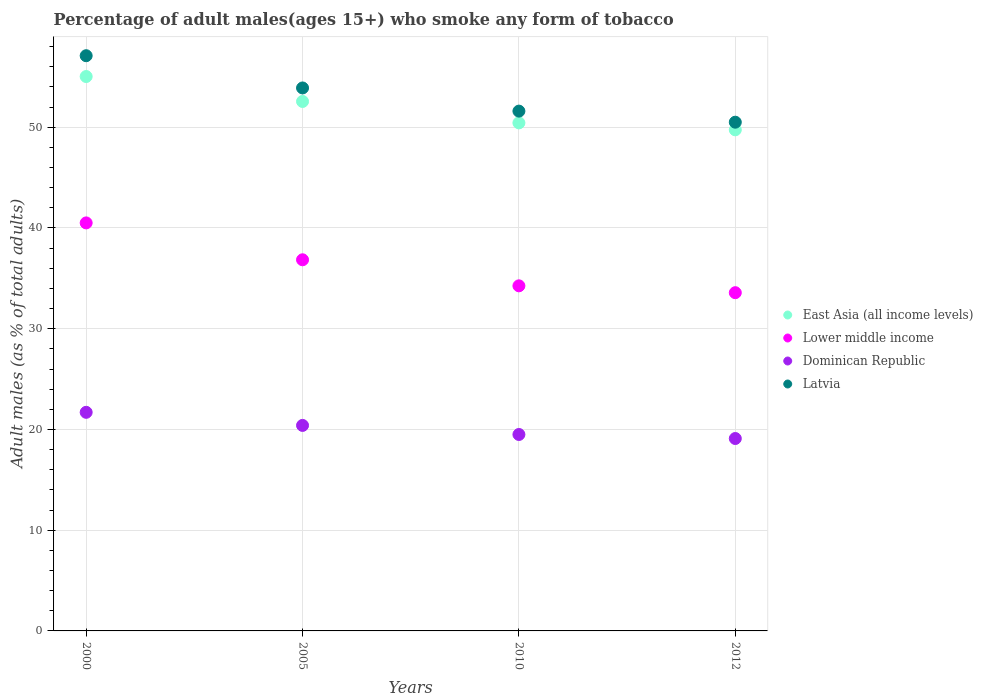How many different coloured dotlines are there?
Provide a succinct answer. 4. What is the percentage of adult males who smoke in Latvia in 2012?
Provide a succinct answer. 50.5. Across all years, what is the maximum percentage of adult males who smoke in Dominican Republic?
Your answer should be compact. 21.7. In which year was the percentage of adult males who smoke in Latvia maximum?
Your answer should be very brief. 2000. In which year was the percentage of adult males who smoke in Lower middle income minimum?
Your answer should be compact. 2012. What is the total percentage of adult males who smoke in Dominican Republic in the graph?
Your answer should be very brief. 80.7. What is the difference between the percentage of adult males who smoke in Latvia in 2000 and that in 2010?
Offer a very short reply. 5.5. What is the difference between the percentage of adult males who smoke in Dominican Republic in 2000 and the percentage of adult males who smoke in East Asia (all income levels) in 2010?
Provide a succinct answer. -28.73. What is the average percentage of adult males who smoke in Latvia per year?
Your response must be concise. 53.27. In the year 2010, what is the difference between the percentage of adult males who smoke in Dominican Republic and percentage of adult males who smoke in East Asia (all income levels)?
Your response must be concise. -30.93. In how many years, is the percentage of adult males who smoke in East Asia (all income levels) greater than 50 %?
Your answer should be compact. 3. What is the ratio of the percentage of adult males who smoke in Latvia in 2000 to that in 2012?
Your answer should be very brief. 1.13. Is the percentage of adult males who smoke in Dominican Republic in 2000 less than that in 2012?
Offer a terse response. No. What is the difference between the highest and the second highest percentage of adult males who smoke in East Asia (all income levels)?
Give a very brief answer. 2.48. What is the difference between the highest and the lowest percentage of adult males who smoke in Dominican Republic?
Your response must be concise. 2.6. Is it the case that in every year, the sum of the percentage of adult males who smoke in Lower middle income and percentage of adult males who smoke in East Asia (all income levels)  is greater than the sum of percentage of adult males who smoke in Dominican Republic and percentage of adult males who smoke in Latvia?
Offer a terse response. No. Is it the case that in every year, the sum of the percentage of adult males who smoke in Latvia and percentage of adult males who smoke in Lower middle income  is greater than the percentage of adult males who smoke in Dominican Republic?
Your answer should be very brief. Yes. Is the percentage of adult males who smoke in Lower middle income strictly less than the percentage of adult males who smoke in Dominican Republic over the years?
Give a very brief answer. No. How many dotlines are there?
Provide a succinct answer. 4. How many years are there in the graph?
Offer a very short reply. 4. What is the difference between two consecutive major ticks on the Y-axis?
Ensure brevity in your answer.  10. Does the graph contain grids?
Your answer should be compact. Yes. How are the legend labels stacked?
Your answer should be very brief. Vertical. What is the title of the graph?
Give a very brief answer. Percentage of adult males(ages 15+) who smoke any form of tobacco. What is the label or title of the Y-axis?
Give a very brief answer. Adult males (as % of total adults). What is the Adult males (as % of total adults) in East Asia (all income levels) in 2000?
Offer a terse response. 55.03. What is the Adult males (as % of total adults) of Lower middle income in 2000?
Your answer should be very brief. 40.5. What is the Adult males (as % of total adults) of Dominican Republic in 2000?
Your answer should be compact. 21.7. What is the Adult males (as % of total adults) in Latvia in 2000?
Offer a very short reply. 57.1. What is the Adult males (as % of total adults) of East Asia (all income levels) in 2005?
Give a very brief answer. 52.56. What is the Adult males (as % of total adults) in Lower middle income in 2005?
Keep it short and to the point. 36.84. What is the Adult males (as % of total adults) in Dominican Republic in 2005?
Make the answer very short. 20.4. What is the Adult males (as % of total adults) of Latvia in 2005?
Provide a short and direct response. 53.9. What is the Adult males (as % of total adults) in East Asia (all income levels) in 2010?
Your answer should be very brief. 50.43. What is the Adult males (as % of total adults) in Lower middle income in 2010?
Offer a terse response. 34.26. What is the Adult males (as % of total adults) in Dominican Republic in 2010?
Offer a very short reply. 19.5. What is the Adult males (as % of total adults) in Latvia in 2010?
Provide a succinct answer. 51.6. What is the Adult males (as % of total adults) of East Asia (all income levels) in 2012?
Your answer should be very brief. 49.74. What is the Adult males (as % of total adults) of Lower middle income in 2012?
Make the answer very short. 33.58. What is the Adult males (as % of total adults) in Dominican Republic in 2012?
Ensure brevity in your answer.  19.1. What is the Adult males (as % of total adults) in Latvia in 2012?
Provide a succinct answer. 50.5. Across all years, what is the maximum Adult males (as % of total adults) in East Asia (all income levels)?
Give a very brief answer. 55.03. Across all years, what is the maximum Adult males (as % of total adults) in Lower middle income?
Ensure brevity in your answer.  40.5. Across all years, what is the maximum Adult males (as % of total adults) of Dominican Republic?
Your answer should be compact. 21.7. Across all years, what is the maximum Adult males (as % of total adults) of Latvia?
Your answer should be compact. 57.1. Across all years, what is the minimum Adult males (as % of total adults) of East Asia (all income levels)?
Your response must be concise. 49.74. Across all years, what is the minimum Adult males (as % of total adults) in Lower middle income?
Provide a short and direct response. 33.58. Across all years, what is the minimum Adult males (as % of total adults) in Dominican Republic?
Provide a succinct answer. 19.1. Across all years, what is the minimum Adult males (as % of total adults) in Latvia?
Ensure brevity in your answer.  50.5. What is the total Adult males (as % of total adults) of East Asia (all income levels) in the graph?
Your answer should be very brief. 207.77. What is the total Adult males (as % of total adults) of Lower middle income in the graph?
Give a very brief answer. 145.18. What is the total Adult males (as % of total adults) of Dominican Republic in the graph?
Offer a very short reply. 80.7. What is the total Adult males (as % of total adults) of Latvia in the graph?
Provide a short and direct response. 213.1. What is the difference between the Adult males (as % of total adults) of East Asia (all income levels) in 2000 and that in 2005?
Offer a very short reply. 2.48. What is the difference between the Adult males (as % of total adults) in Lower middle income in 2000 and that in 2005?
Give a very brief answer. 3.66. What is the difference between the Adult males (as % of total adults) of Dominican Republic in 2000 and that in 2005?
Provide a succinct answer. 1.3. What is the difference between the Adult males (as % of total adults) in Latvia in 2000 and that in 2005?
Your answer should be compact. 3.2. What is the difference between the Adult males (as % of total adults) in East Asia (all income levels) in 2000 and that in 2010?
Ensure brevity in your answer.  4.6. What is the difference between the Adult males (as % of total adults) in Lower middle income in 2000 and that in 2010?
Your answer should be very brief. 6.25. What is the difference between the Adult males (as % of total adults) in East Asia (all income levels) in 2000 and that in 2012?
Offer a terse response. 5.29. What is the difference between the Adult males (as % of total adults) of Lower middle income in 2000 and that in 2012?
Your answer should be very brief. 6.93. What is the difference between the Adult males (as % of total adults) of Latvia in 2000 and that in 2012?
Offer a terse response. 6.6. What is the difference between the Adult males (as % of total adults) in East Asia (all income levels) in 2005 and that in 2010?
Ensure brevity in your answer.  2.13. What is the difference between the Adult males (as % of total adults) of Lower middle income in 2005 and that in 2010?
Your answer should be compact. 2.59. What is the difference between the Adult males (as % of total adults) in Dominican Republic in 2005 and that in 2010?
Give a very brief answer. 0.9. What is the difference between the Adult males (as % of total adults) in East Asia (all income levels) in 2005 and that in 2012?
Provide a succinct answer. 2.81. What is the difference between the Adult males (as % of total adults) in Lower middle income in 2005 and that in 2012?
Provide a short and direct response. 3.27. What is the difference between the Adult males (as % of total adults) in Dominican Republic in 2005 and that in 2012?
Provide a short and direct response. 1.3. What is the difference between the Adult males (as % of total adults) of Latvia in 2005 and that in 2012?
Your answer should be very brief. 3.4. What is the difference between the Adult males (as % of total adults) in East Asia (all income levels) in 2010 and that in 2012?
Keep it short and to the point. 0.69. What is the difference between the Adult males (as % of total adults) in Lower middle income in 2010 and that in 2012?
Keep it short and to the point. 0.68. What is the difference between the Adult males (as % of total adults) of Latvia in 2010 and that in 2012?
Keep it short and to the point. 1.1. What is the difference between the Adult males (as % of total adults) of East Asia (all income levels) in 2000 and the Adult males (as % of total adults) of Lower middle income in 2005?
Ensure brevity in your answer.  18.19. What is the difference between the Adult males (as % of total adults) of East Asia (all income levels) in 2000 and the Adult males (as % of total adults) of Dominican Republic in 2005?
Ensure brevity in your answer.  34.63. What is the difference between the Adult males (as % of total adults) in East Asia (all income levels) in 2000 and the Adult males (as % of total adults) in Latvia in 2005?
Give a very brief answer. 1.13. What is the difference between the Adult males (as % of total adults) of Lower middle income in 2000 and the Adult males (as % of total adults) of Dominican Republic in 2005?
Your answer should be compact. 20.1. What is the difference between the Adult males (as % of total adults) of Lower middle income in 2000 and the Adult males (as % of total adults) of Latvia in 2005?
Make the answer very short. -13.4. What is the difference between the Adult males (as % of total adults) of Dominican Republic in 2000 and the Adult males (as % of total adults) of Latvia in 2005?
Your answer should be compact. -32.2. What is the difference between the Adult males (as % of total adults) in East Asia (all income levels) in 2000 and the Adult males (as % of total adults) in Lower middle income in 2010?
Give a very brief answer. 20.78. What is the difference between the Adult males (as % of total adults) of East Asia (all income levels) in 2000 and the Adult males (as % of total adults) of Dominican Republic in 2010?
Give a very brief answer. 35.53. What is the difference between the Adult males (as % of total adults) in East Asia (all income levels) in 2000 and the Adult males (as % of total adults) in Latvia in 2010?
Keep it short and to the point. 3.43. What is the difference between the Adult males (as % of total adults) in Lower middle income in 2000 and the Adult males (as % of total adults) in Dominican Republic in 2010?
Provide a succinct answer. 21. What is the difference between the Adult males (as % of total adults) of Lower middle income in 2000 and the Adult males (as % of total adults) of Latvia in 2010?
Provide a succinct answer. -11.1. What is the difference between the Adult males (as % of total adults) of Dominican Republic in 2000 and the Adult males (as % of total adults) of Latvia in 2010?
Provide a succinct answer. -29.9. What is the difference between the Adult males (as % of total adults) of East Asia (all income levels) in 2000 and the Adult males (as % of total adults) of Lower middle income in 2012?
Your response must be concise. 21.46. What is the difference between the Adult males (as % of total adults) of East Asia (all income levels) in 2000 and the Adult males (as % of total adults) of Dominican Republic in 2012?
Your answer should be compact. 35.93. What is the difference between the Adult males (as % of total adults) in East Asia (all income levels) in 2000 and the Adult males (as % of total adults) in Latvia in 2012?
Provide a short and direct response. 4.53. What is the difference between the Adult males (as % of total adults) in Lower middle income in 2000 and the Adult males (as % of total adults) in Dominican Republic in 2012?
Ensure brevity in your answer.  21.4. What is the difference between the Adult males (as % of total adults) in Lower middle income in 2000 and the Adult males (as % of total adults) in Latvia in 2012?
Offer a terse response. -10. What is the difference between the Adult males (as % of total adults) of Dominican Republic in 2000 and the Adult males (as % of total adults) of Latvia in 2012?
Your response must be concise. -28.8. What is the difference between the Adult males (as % of total adults) in East Asia (all income levels) in 2005 and the Adult males (as % of total adults) in Lower middle income in 2010?
Your response must be concise. 18.3. What is the difference between the Adult males (as % of total adults) in East Asia (all income levels) in 2005 and the Adult males (as % of total adults) in Dominican Republic in 2010?
Give a very brief answer. 33.06. What is the difference between the Adult males (as % of total adults) of East Asia (all income levels) in 2005 and the Adult males (as % of total adults) of Latvia in 2010?
Ensure brevity in your answer.  0.96. What is the difference between the Adult males (as % of total adults) in Lower middle income in 2005 and the Adult males (as % of total adults) in Dominican Republic in 2010?
Provide a short and direct response. 17.34. What is the difference between the Adult males (as % of total adults) of Lower middle income in 2005 and the Adult males (as % of total adults) of Latvia in 2010?
Offer a terse response. -14.76. What is the difference between the Adult males (as % of total adults) of Dominican Republic in 2005 and the Adult males (as % of total adults) of Latvia in 2010?
Your answer should be compact. -31.2. What is the difference between the Adult males (as % of total adults) of East Asia (all income levels) in 2005 and the Adult males (as % of total adults) of Lower middle income in 2012?
Keep it short and to the point. 18.98. What is the difference between the Adult males (as % of total adults) of East Asia (all income levels) in 2005 and the Adult males (as % of total adults) of Dominican Republic in 2012?
Offer a terse response. 33.46. What is the difference between the Adult males (as % of total adults) of East Asia (all income levels) in 2005 and the Adult males (as % of total adults) of Latvia in 2012?
Offer a very short reply. 2.06. What is the difference between the Adult males (as % of total adults) of Lower middle income in 2005 and the Adult males (as % of total adults) of Dominican Republic in 2012?
Offer a very short reply. 17.74. What is the difference between the Adult males (as % of total adults) of Lower middle income in 2005 and the Adult males (as % of total adults) of Latvia in 2012?
Provide a succinct answer. -13.66. What is the difference between the Adult males (as % of total adults) of Dominican Republic in 2005 and the Adult males (as % of total adults) of Latvia in 2012?
Offer a terse response. -30.1. What is the difference between the Adult males (as % of total adults) in East Asia (all income levels) in 2010 and the Adult males (as % of total adults) in Lower middle income in 2012?
Give a very brief answer. 16.86. What is the difference between the Adult males (as % of total adults) of East Asia (all income levels) in 2010 and the Adult males (as % of total adults) of Dominican Republic in 2012?
Offer a terse response. 31.33. What is the difference between the Adult males (as % of total adults) in East Asia (all income levels) in 2010 and the Adult males (as % of total adults) in Latvia in 2012?
Give a very brief answer. -0.07. What is the difference between the Adult males (as % of total adults) of Lower middle income in 2010 and the Adult males (as % of total adults) of Dominican Republic in 2012?
Ensure brevity in your answer.  15.16. What is the difference between the Adult males (as % of total adults) of Lower middle income in 2010 and the Adult males (as % of total adults) of Latvia in 2012?
Ensure brevity in your answer.  -16.24. What is the difference between the Adult males (as % of total adults) in Dominican Republic in 2010 and the Adult males (as % of total adults) in Latvia in 2012?
Offer a terse response. -31. What is the average Adult males (as % of total adults) in East Asia (all income levels) per year?
Keep it short and to the point. 51.94. What is the average Adult males (as % of total adults) of Lower middle income per year?
Make the answer very short. 36.29. What is the average Adult males (as % of total adults) in Dominican Republic per year?
Offer a very short reply. 20.18. What is the average Adult males (as % of total adults) in Latvia per year?
Your response must be concise. 53.27. In the year 2000, what is the difference between the Adult males (as % of total adults) of East Asia (all income levels) and Adult males (as % of total adults) of Lower middle income?
Ensure brevity in your answer.  14.53. In the year 2000, what is the difference between the Adult males (as % of total adults) in East Asia (all income levels) and Adult males (as % of total adults) in Dominican Republic?
Your response must be concise. 33.33. In the year 2000, what is the difference between the Adult males (as % of total adults) in East Asia (all income levels) and Adult males (as % of total adults) in Latvia?
Provide a succinct answer. -2.07. In the year 2000, what is the difference between the Adult males (as % of total adults) of Lower middle income and Adult males (as % of total adults) of Dominican Republic?
Provide a succinct answer. 18.8. In the year 2000, what is the difference between the Adult males (as % of total adults) in Lower middle income and Adult males (as % of total adults) in Latvia?
Provide a succinct answer. -16.6. In the year 2000, what is the difference between the Adult males (as % of total adults) in Dominican Republic and Adult males (as % of total adults) in Latvia?
Provide a short and direct response. -35.4. In the year 2005, what is the difference between the Adult males (as % of total adults) in East Asia (all income levels) and Adult males (as % of total adults) in Lower middle income?
Give a very brief answer. 15.72. In the year 2005, what is the difference between the Adult males (as % of total adults) of East Asia (all income levels) and Adult males (as % of total adults) of Dominican Republic?
Offer a very short reply. 32.16. In the year 2005, what is the difference between the Adult males (as % of total adults) in East Asia (all income levels) and Adult males (as % of total adults) in Latvia?
Make the answer very short. -1.34. In the year 2005, what is the difference between the Adult males (as % of total adults) of Lower middle income and Adult males (as % of total adults) of Dominican Republic?
Make the answer very short. 16.44. In the year 2005, what is the difference between the Adult males (as % of total adults) in Lower middle income and Adult males (as % of total adults) in Latvia?
Make the answer very short. -17.06. In the year 2005, what is the difference between the Adult males (as % of total adults) of Dominican Republic and Adult males (as % of total adults) of Latvia?
Offer a very short reply. -33.5. In the year 2010, what is the difference between the Adult males (as % of total adults) of East Asia (all income levels) and Adult males (as % of total adults) of Lower middle income?
Your answer should be very brief. 16.18. In the year 2010, what is the difference between the Adult males (as % of total adults) in East Asia (all income levels) and Adult males (as % of total adults) in Dominican Republic?
Make the answer very short. 30.93. In the year 2010, what is the difference between the Adult males (as % of total adults) in East Asia (all income levels) and Adult males (as % of total adults) in Latvia?
Provide a short and direct response. -1.17. In the year 2010, what is the difference between the Adult males (as % of total adults) in Lower middle income and Adult males (as % of total adults) in Dominican Republic?
Make the answer very short. 14.76. In the year 2010, what is the difference between the Adult males (as % of total adults) of Lower middle income and Adult males (as % of total adults) of Latvia?
Offer a very short reply. -17.34. In the year 2010, what is the difference between the Adult males (as % of total adults) in Dominican Republic and Adult males (as % of total adults) in Latvia?
Provide a succinct answer. -32.1. In the year 2012, what is the difference between the Adult males (as % of total adults) of East Asia (all income levels) and Adult males (as % of total adults) of Lower middle income?
Give a very brief answer. 16.17. In the year 2012, what is the difference between the Adult males (as % of total adults) of East Asia (all income levels) and Adult males (as % of total adults) of Dominican Republic?
Your answer should be compact. 30.64. In the year 2012, what is the difference between the Adult males (as % of total adults) in East Asia (all income levels) and Adult males (as % of total adults) in Latvia?
Provide a succinct answer. -0.76. In the year 2012, what is the difference between the Adult males (as % of total adults) of Lower middle income and Adult males (as % of total adults) of Dominican Republic?
Give a very brief answer. 14.48. In the year 2012, what is the difference between the Adult males (as % of total adults) of Lower middle income and Adult males (as % of total adults) of Latvia?
Provide a short and direct response. -16.92. In the year 2012, what is the difference between the Adult males (as % of total adults) in Dominican Republic and Adult males (as % of total adults) in Latvia?
Your answer should be very brief. -31.4. What is the ratio of the Adult males (as % of total adults) in East Asia (all income levels) in 2000 to that in 2005?
Give a very brief answer. 1.05. What is the ratio of the Adult males (as % of total adults) in Lower middle income in 2000 to that in 2005?
Your answer should be compact. 1.1. What is the ratio of the Adult males (as % of total adults) in Dominican Republic in 2000 to that in 2005?
Provide a short and direct response. 1.06. What is the ratio of the Adult males (as % of total adults) of Latvia in 2000 to that in 2005?
Ensure brevity in your answer.  1.06. What is the ratio of the Adult males (as % of total adults) in East Asia (all income levels) in 2000 to that in 2010?
Offer a very short reply. 1.09. What is the ratio of the Adult males (as % of total adults) of Lower middle income in 2000 to that in 2010?
Your answer should be compact. 1.18. What is the ratio of the Adult males (as % of total adults) of Dominican Republic in 2000 to that in 2010?
Offer a terse response. 1.11. What is the ratio of the Adult males (as % of total adults) of Latvia in 2000 to that in 2010?
Provide a succinct answer. 1.11. What is the ratio of the Adult males (as % of total adults) of East Asia (all income levels) in 2000 to that in 2012?
Offer a terse response. 1.11. What is the ratio of the Adult males (as % of total adults) in Lower middle income in 2000 to that in 2012?
Make the answer very short. 1.21. What is the ratio of the Adult males (as % of total adults) of Dominican Republic in 2000 to that in 2012?
Offer a terse response. 1.14. What is the ratio of the Adult males (as % of total adults) of Latvia in 2000 to that in 2012?
Make the answer very short. 1.13. What is the ratio of the Adult males (as % of total adults) in East Asia (all income levels) in 2005 to that in 2010?
Provide a succinct answer. 1.04. What is the ratio of the Adult males (as % of total adults) in Lower middle income in 2005 to that in 2010?
Provide a succinct answer. 1.08. What is the ratio of the Adult males (as % of total adults) of Dominican Republic in 2005 to that in 2010?
Give a very brief answer. 1.05. What is the ratio of the Adult males (as % of total adults) of Latvia in 2005 to that in 2010?
Your answer should be very brief. 1.04. What is the ratio of the Adult males (as % of total adults) of East Asia (all income levels) in 2005 to that in 2012?
Your answer should be compact. 1.06. What is the ratio of the Adult males (as % of total adults) of Lower middle income in 2005 to that in 2012?
Provide a short and direct response. 1.1. What is the ratio of the Adult males (as % of total adults) of Dominican Republic in 2005 to that in 2012?
Your answer should be compact. 1.07. What is the ratio of the Adult males (as % of total adults) of Latvia in 2005 to that in 2012?
Provide a succinct answer. 1.07. What is the ratio of the Adult males (as % of total adults) in East Asia (all income levels) in 2010 to that in 2012?
Your answer should be compact. 1.01. What is the ratio of the Adult males (as % of total adults) of Lower middle income in 2010 to that in 2012?
Offer a terse response. 1.02. What is the ratio of the Adult males (as % of total adults) in Dominican Republic in 2010 to that in 2012?
Your response must be concise. 1.02. What is the ratio of the Adult males (as % of total adults) of Latvia in 2010 to that in 2012?
Make the answer very short. 1.02. What is the difference between the highest and the second highest Adult males (as % of total adults) of East Asia (all income levels)?
Make the answer very short. 2.48. What is the difference between the highest and the second highest Adult males (as % of total adults) of Lower middle income?
Your response must be concise. 3.66. What is the difference between the highest and the second highest Adult males (as % of total adults) in Dominican Republic?
Ensure brevity in your answer.  1.3. What is the difference between the highest and the second highest Adult males (as % of total adults) in Latvia?
Provide a short and direct response. 3.2. What is the difference between the highest and the lowest Adult males (as % of total adults) in East Asia (all income levels)?
Provide a succinct answer. 5.29. What is the difference between the highest and the lowest Adult males (as % of total adults) of Lower middle income?
Your answer should be very brief. 6.93. What is the difference between the highest and the lowest Adult males (as % of total adults) in Latvia?
Offer a very short reply. 6.6. 